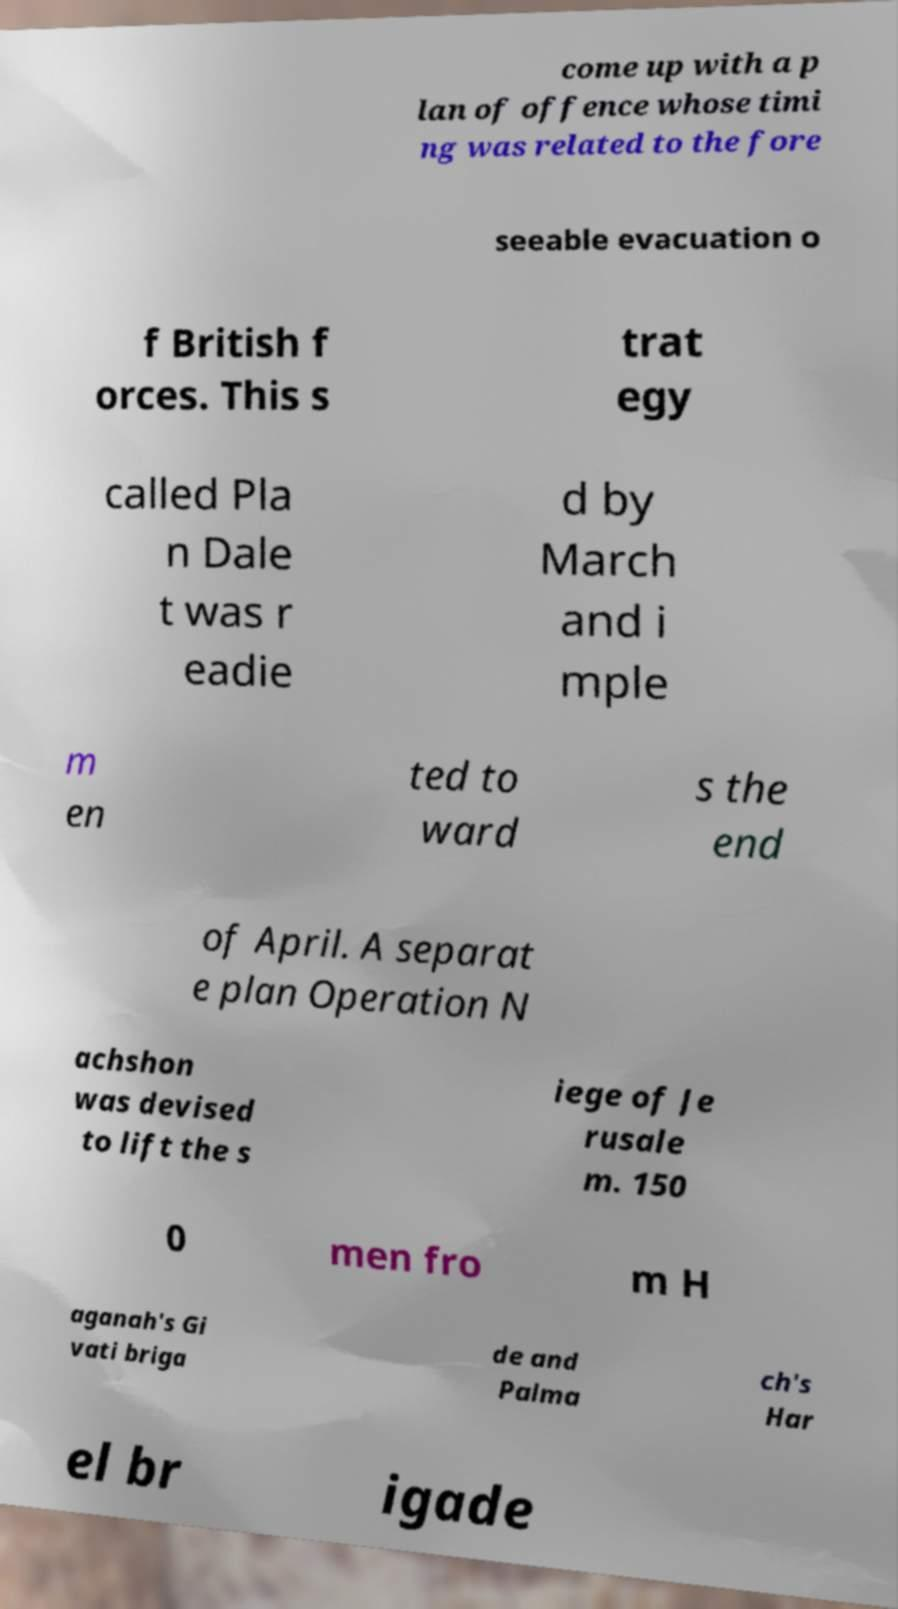Could you assist in decoding the text presented in this image and type it out clearly? come up with a p lan of offence whose timi ng was related to the fore seeable evacuation o f British f orces. This s trat egy called Pla n Dale t was r eadie d by March and i mple m en ted to ward s the end of April. A separat e plan Operation N achshon was devised to lift the s iege of Je rusale m. 150 0 men fro m H aganah's Gi vati briga de and Palma ch's Har el br igade 